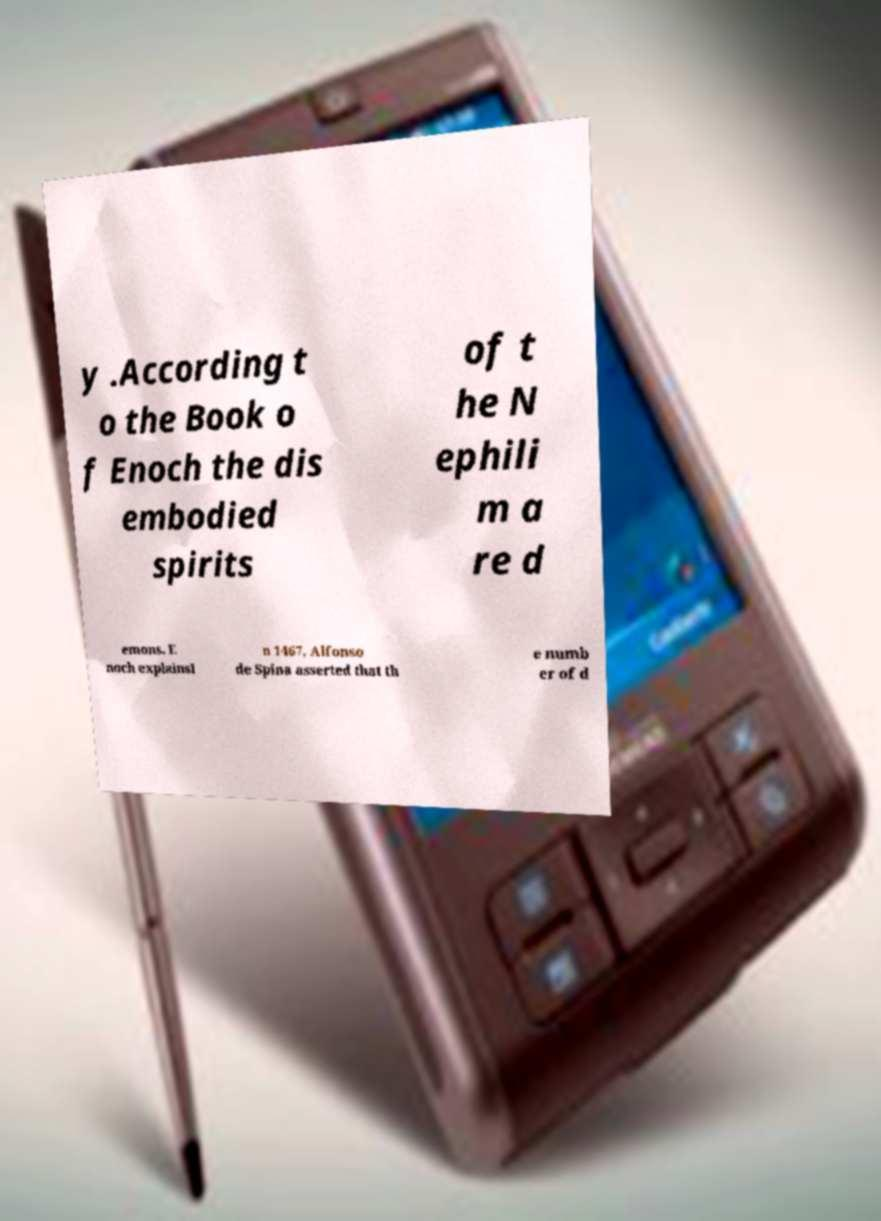Can you accurately transcribe the text from the provided image for me? y .According t o the Book o f Enoch the dis embodied spirits of t he N ephili m a re d emons. E noch explainsI n 1467, Alfonso de Spina asserted that th e numb er of d 